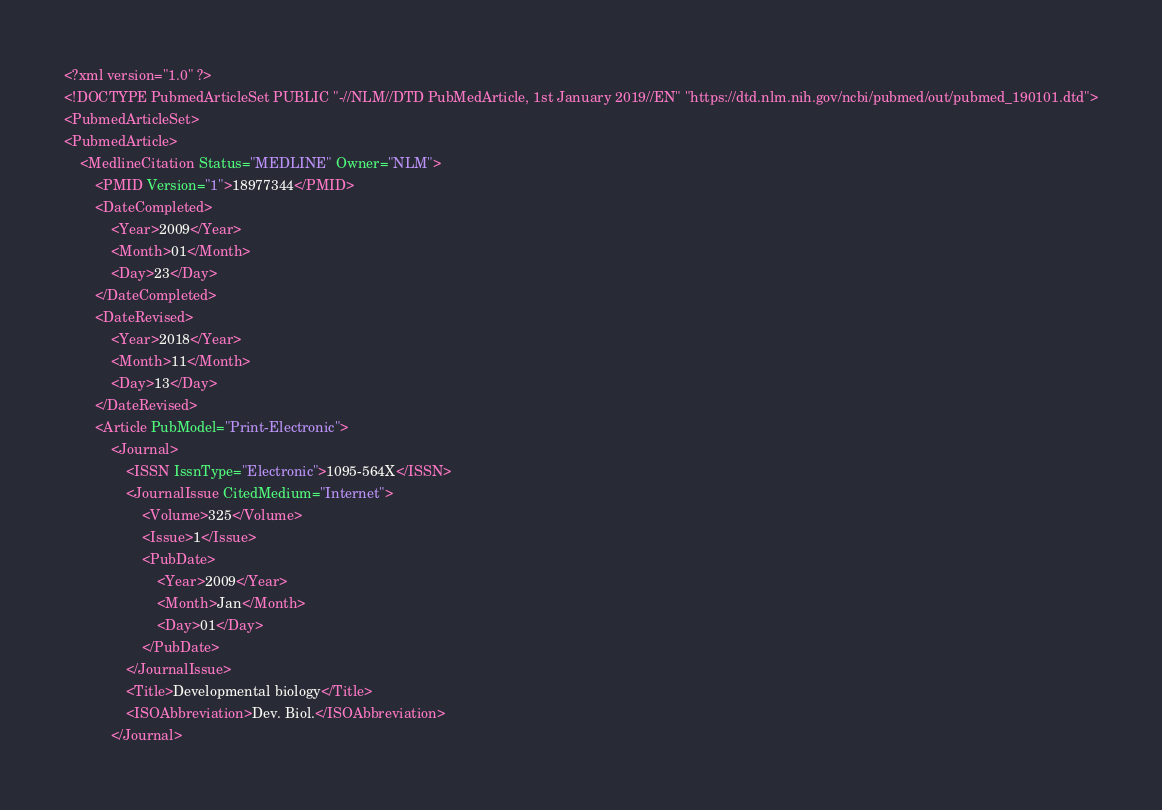<code> <loc_0><loc_0><loc_500><loc_500><_XML_><?xml version="1.0" ?>
<!DOCTYPE PubmedArticleSet PUBLIC "-//NLM//DTD PubMedArticle, 1st January 2019//EN" "https://dtd.nlm.nih.gov/ncbi/pubmed/out/pubmed_190101.dtd">
<PubmedArticleSet>
<PubmedArticle>
    <MedlineCitation Status="MEDLINE" Owner="NLM">
        <PMID Version="1">18977344</PMID>
        <DateCompleted>
            <Year>2009</Year>
            <Month>01</Month>
            <Day>23</Day>
        </DateCompleted>
        <DateRevised>
            <Year>2018</Year>
            <Month>11</Month>
            <Day>13</Day>
        </DateRevised>
        <Article PubModel="Print-Electronic">
            <Journal>
                <ISSN IssnType="Electronic">1095-564X</ISSN>
                <JournalIssue CitedMedium="Internet">
                    <Volume>325</Volume>
                    <Issue>1</Issue>
                    <PubDate>
                        <Year>2009</Year>
                        <Month>Jan</Month>
                        <Day>01</Day>
                    </PubDate>
                </JournalIssue>
                <Title>Developmental biology</Title>
                <ISOAbbreviation>Dev. Biol.</ISOAbbreviation>
            </Journal></code> 